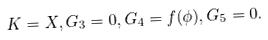<formula> <loc_0><loc_0><loc_500><loc_500>K = X , G _ { 3 } = 0 , G _ { 4 } = f ( \phi ) , G _ { 5 } = 0 .</formula> 